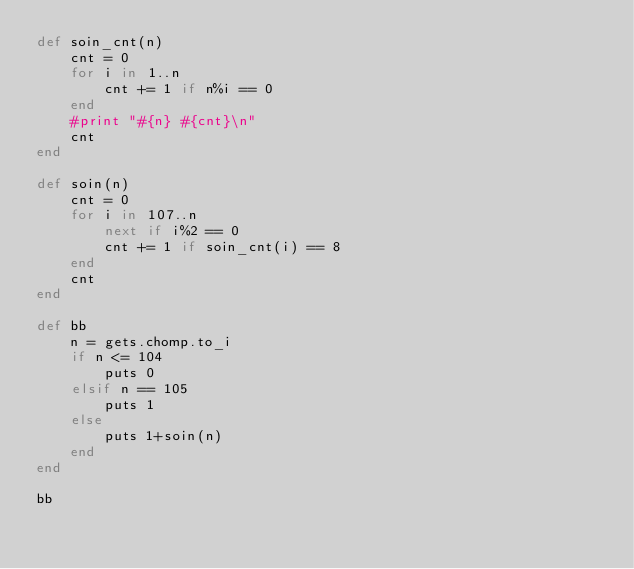Convert code to text. <code><loc_0><loc_0><loc_500><loc_500><_Ruby_>def soin_cnt(n)
    cnt = 0
    for i in 1..n
        cnt += 1 if n%i == 0
    end
    #print "#{n} #{cnt}\n"
    cnt
end

def soin(n)
    cnt = 0
    for i in 107..n
        next if i%2 == 0
        cnt += 1 if soin_cnt(i) == 8
    end
    cnt
end

def bb
    n = gets.chomp.to_i
    if n <= 104
        puts 0
    elsif n == 105
        puts 1
    else
        puts 1+soin(n)
    end
end

bb</code> 